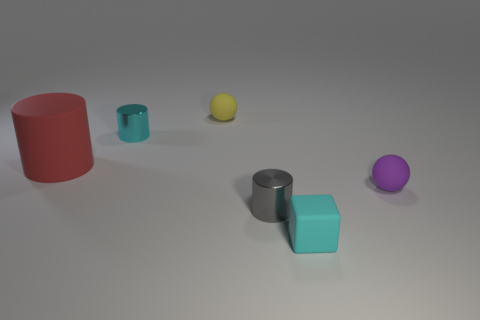Is the tiny cyan cylinder made of the same material as the yellow sphere?
Offer a terse response. No. There is a shiny cylinder that is left of the gray metallic object; does it have the same color as the matte cube?
Your answer should be very brief. Yes. Are there any small metal cylinders of the same color as the rubber cube?
Provide a short and direct response. Yes. Does the small cylinder in front of the large rubber object have the same material as the tiny cyan cube?
Keep it short and to the point. No. There is a tiny cyan thing in front of the big red cylinder; is its shape the same as the small cyan thing left of the gray cylinder?
Provide a short and direct response. No. The sphere to the left of the matte sphere in front of the ball left of the cyan matte block is what color?
Your answer should be very brief. Yellow. How many matte objects are in front of the tiny yellow object and left of the small cyan cube?
Keep it short and to the point. 1. How many cylinders are small objects or cyan things?
Give a very brief answer. 2. Are there any red cubes?
Keep it short and to the point. No. What number of other objects are there of the same material as the small yellow thing?
Ensure brevity in your answer.  3. 